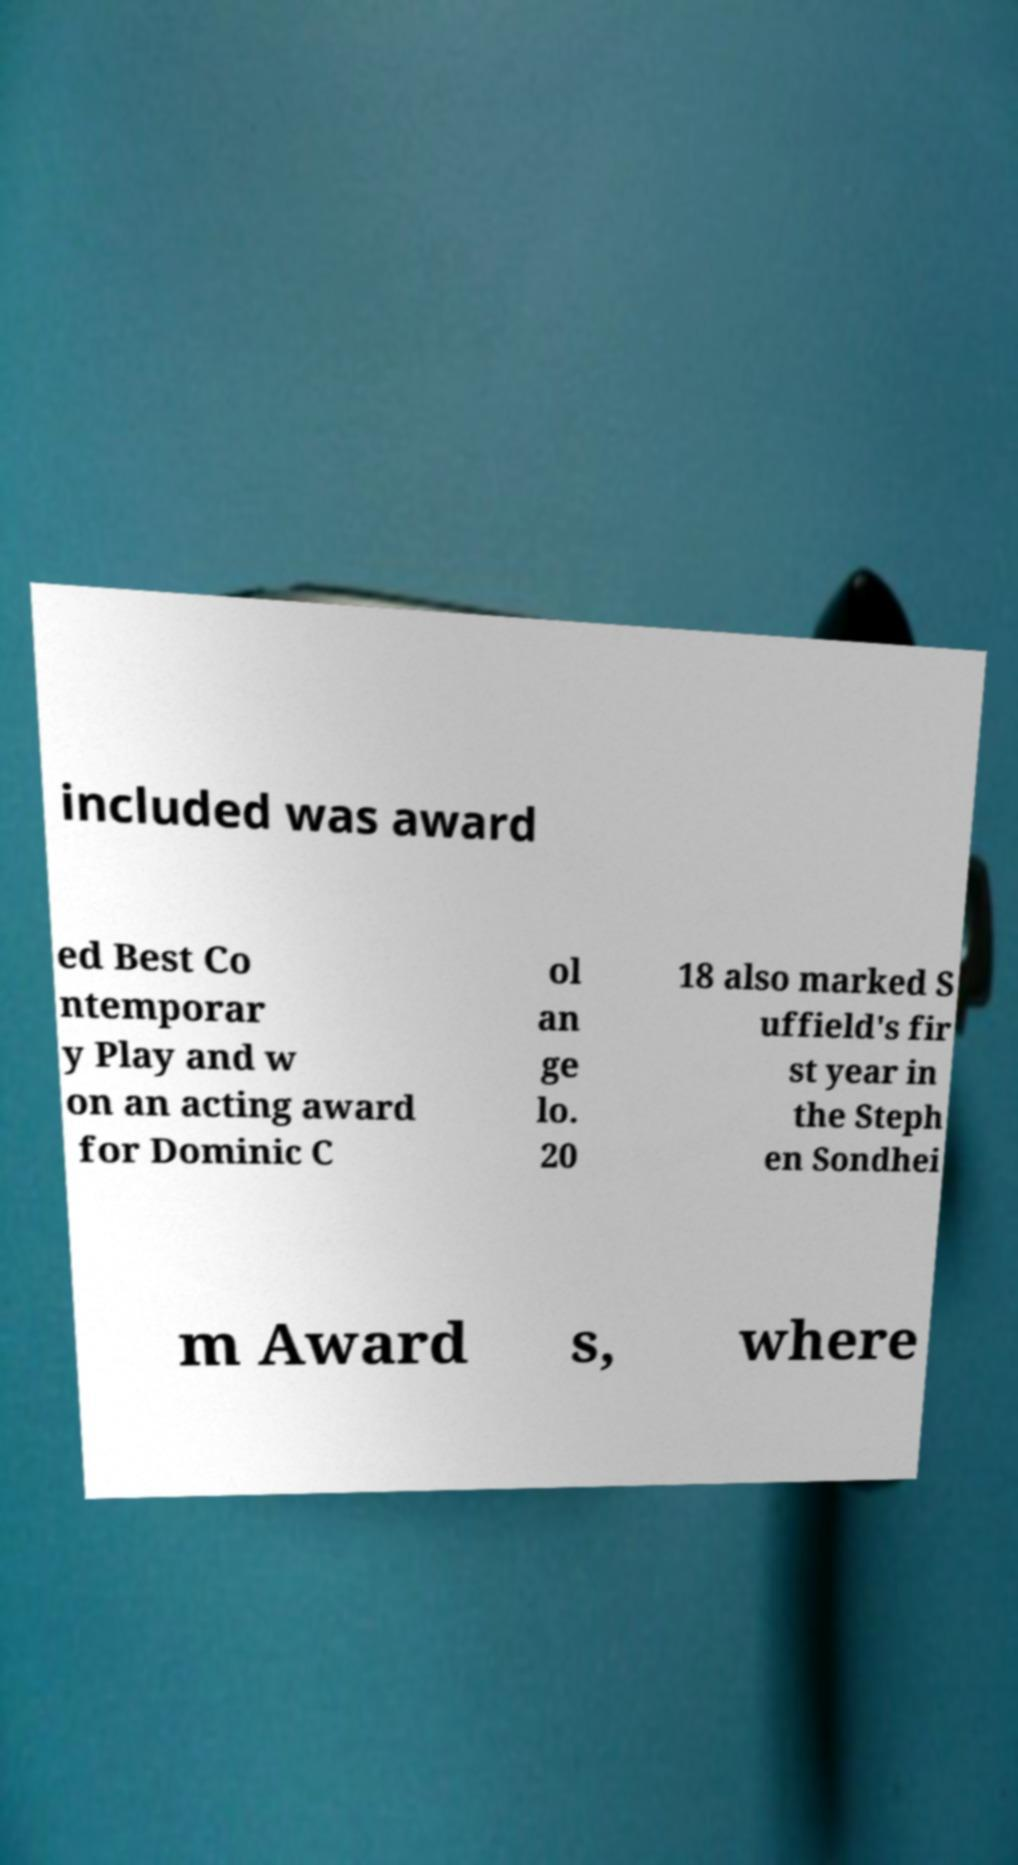There's text embedded in this image that I need extracted. Can you transcribe it verbatim? included was award ed Best Co ntemporar y Play and w on an acting award for Dominic C ol an ge lo. 20 18 also marked S uffield's fir st year in the Steph en Sondhei m Award s, where 